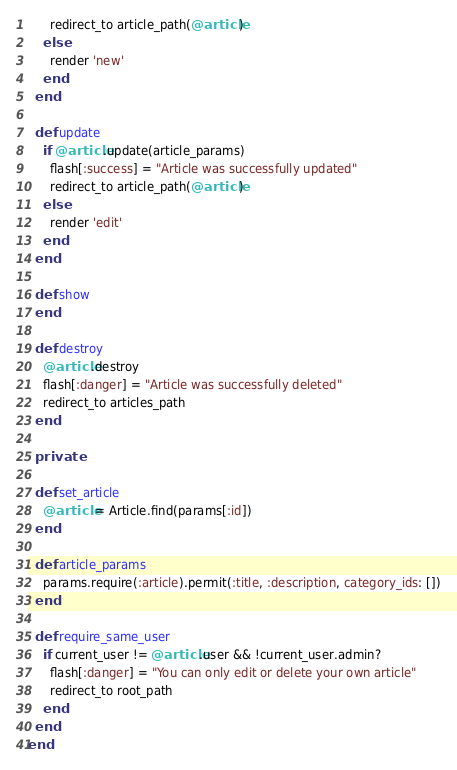Convert code to text. <code><loc_0><loc_0><loc_500><loc_500><_Ruby_>      redirect_to article_path(@article)
    else
      render 'new'
    end
  end
  
  def update
    if @article.update(article_params)
      flash[:success] = "Article was successfully updated"
      redirect_to article_path(@article)
    else
      render 'edit'
    end
  end
  
  def show
  end
  
  def destroy
    @article.destroy
    flash[:danger] = "Article was successfully deleted"
    redirect_to articles_path
  end
  
  private
  
  def set_article
    @article = Article.find(params[:id])
  end
  
  def article_params
    params.require(:article).permit(:title, :description, category_ids: [])
  end

  def require_same_user
    if current_user != @article.user && !current_user.admin?
      flash[:danger] = "You can only edit or delete your own article"
      redirect_to root_path
    end
  end
end</code> 